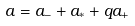<formula> <loc_0><loc_0><loc_500><loc_500>a = a _ { - } + a _ { * } + q a _ { + }</formula> 